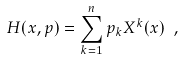<formula> <loc_0><loc_0><loc_500><loc_500>H ( x , p ) = \sum _ { k = 1 } ^ { n } p _ { k } X ^ { k } ( x ) \ ,</formula> 